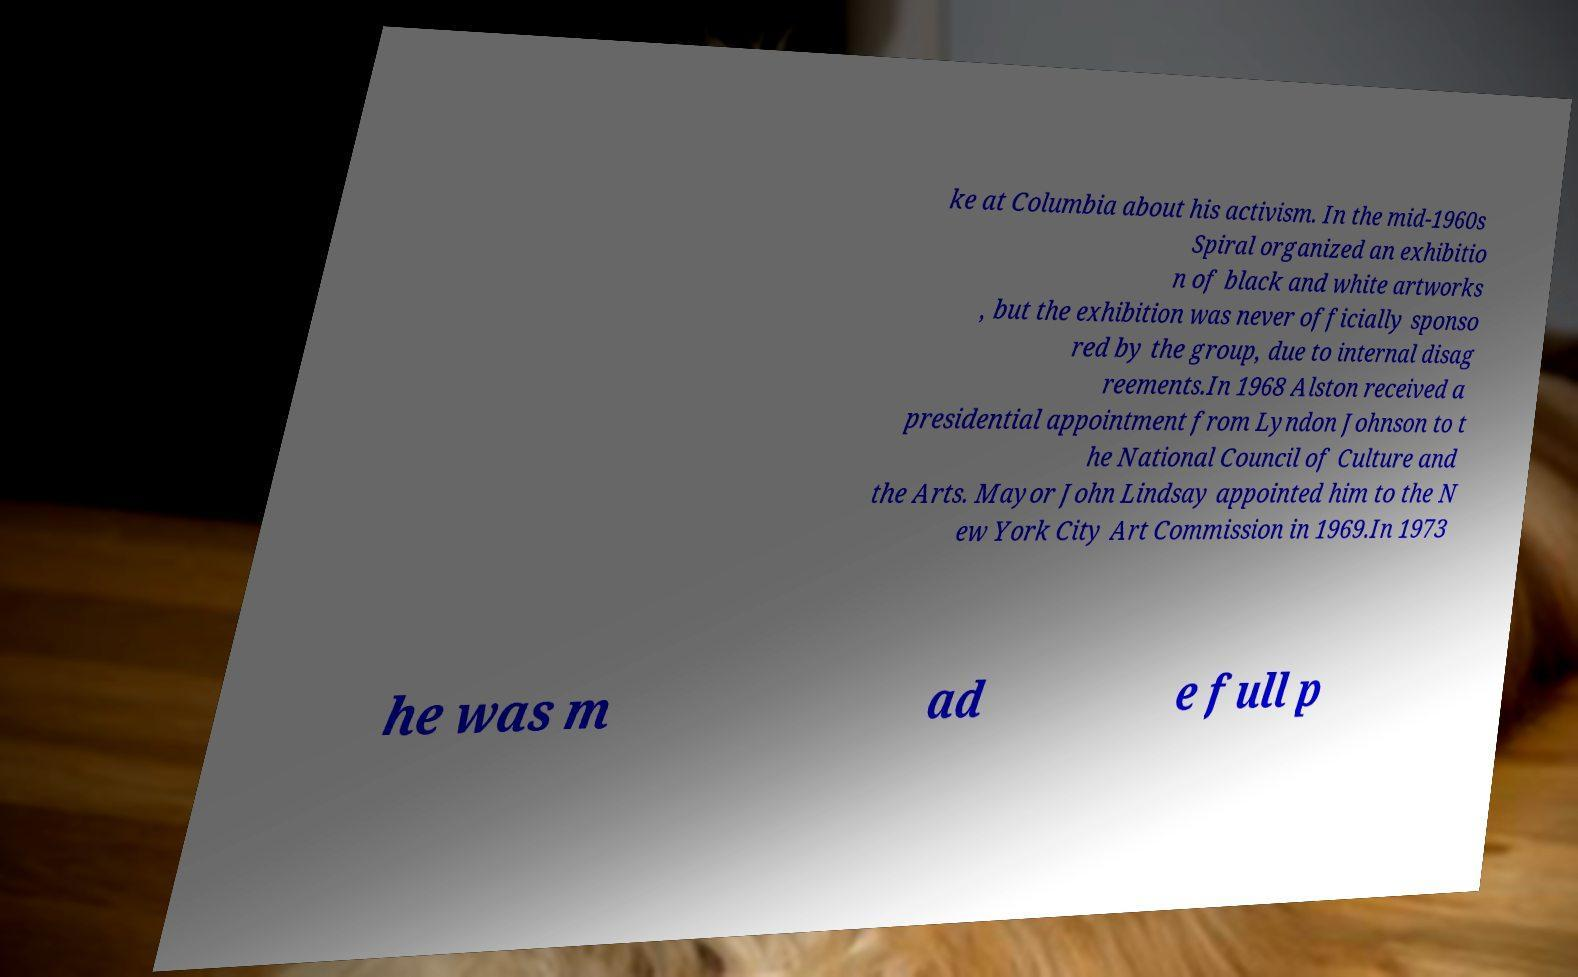Please identify and transcribe the text found in this image. ke at Columbia about his activism. In the mid-1960s Spiral organized an exhibitio n of black and white artworks , but the exhibition was never officially sponso red by the group, due to internal disag reements.In 1968 Alston received a presidential appointment from Lyndon Johnson to t he National Council of Culture and the Arts. Mayor John Lindsay appointed him to the N ew York City Art Commission in 1969.In 1973 he was m ad e full p 